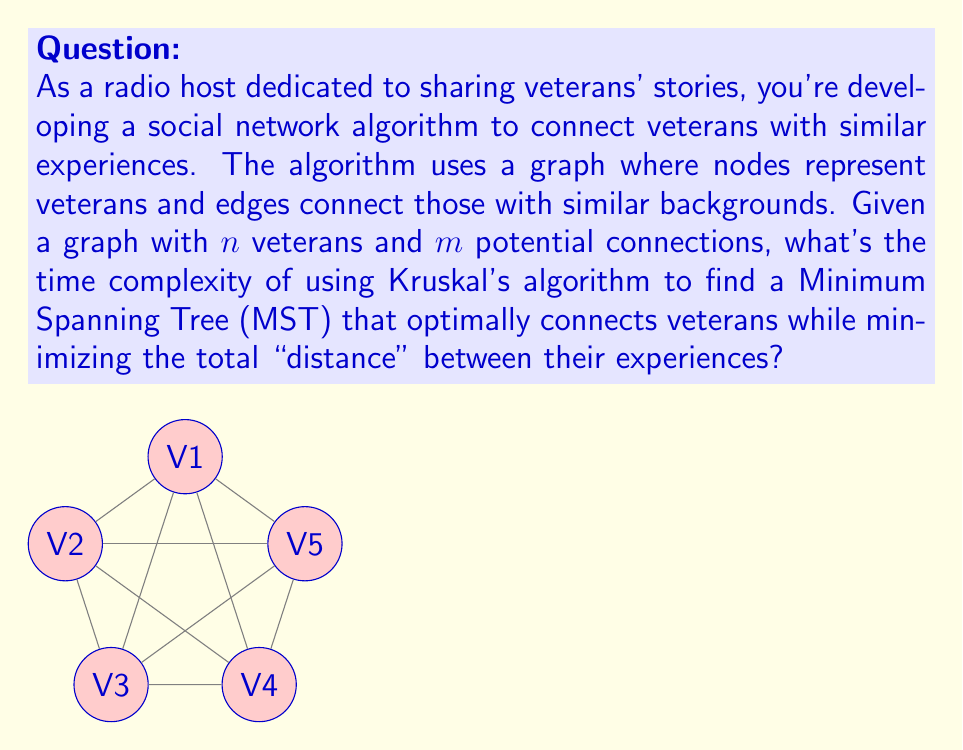Can you solve this math problem? To analyze the time complexity of Kruskal's algorithm for this veteran connection problem, let's break it down step-by-step:

1) Sorting the edges: 
   - There are $m$ edges in total.
   - Sorting these edges takes $O(m \log m)$ time using an efficient sorting algorithm like Merge Sort or Heap Sort.

2) Processing the edges:
   - We iterate through all $m$ edges.
   - For each edge, we perform two operations:
     a) Find operation to check if the vertices are in the same set.
     b) Union operation to merge sets if the vertices are in different sets.
   - With path compression and union by rank optimizations, both Find and Union operations have an amortized time complexity of $O(\alpha(n))$, where $\alpha(n)$ is the inverse Ackermann function.
   - $\alpha(n)$ grows extremely slowly and is effectively constant for all practical values of $n$.

3) Total time complexity:
   $$ T(n,m) = O(m \log m) + O(m \cdot \alpha(n)) $$

4) Simplification:
   - Since $m$ can be at most $\frac{n(n-1)}{2}$ (in a complete graph), $\log m = O(\log n)$.
   - $\alpha(n)$ is effectively constant.

Therefore, the dominant term is $O(m \log m)$, which simplifies to $O(m \log n)$.
Answer: $O(m \log n)$ 